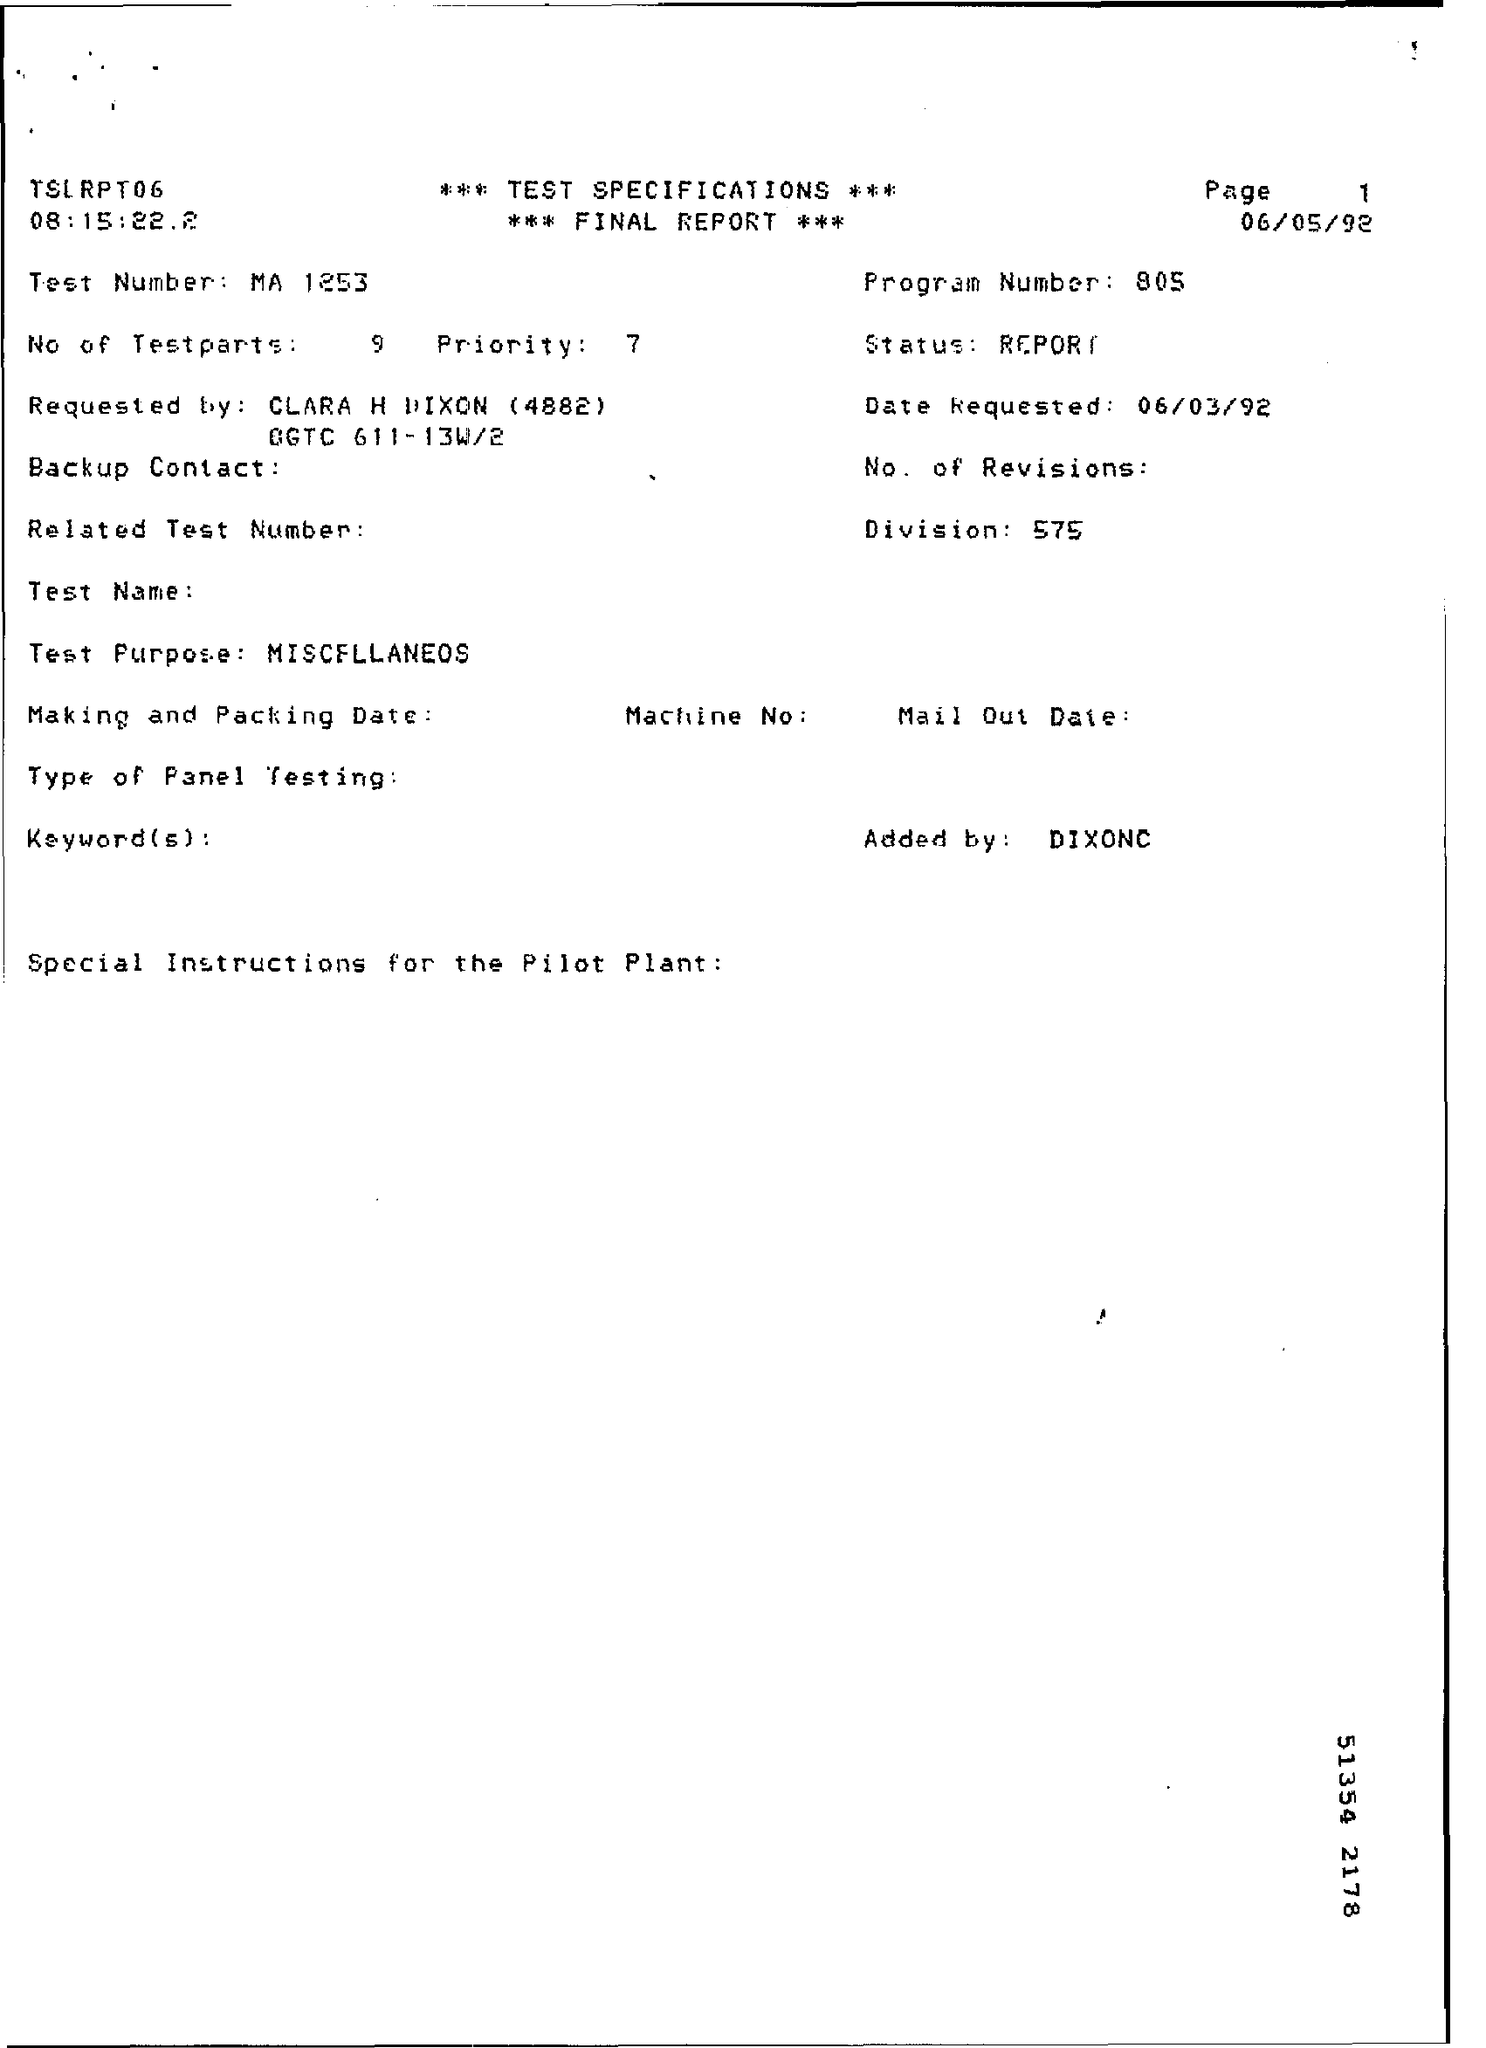What is the test number given in the final report?
Give a very brief answer. MA 1253. What is the program number mentioned in the final report?
Give a very brief answer. 805. What is the No of Test parts as per the report?
Keep it short and to the point. 9. What is the requested date given in the final report?
Ensure brevity in your answer.  06/03/92. What is the Division no mentIoned in the report?
Give a very brief answer. 575. 